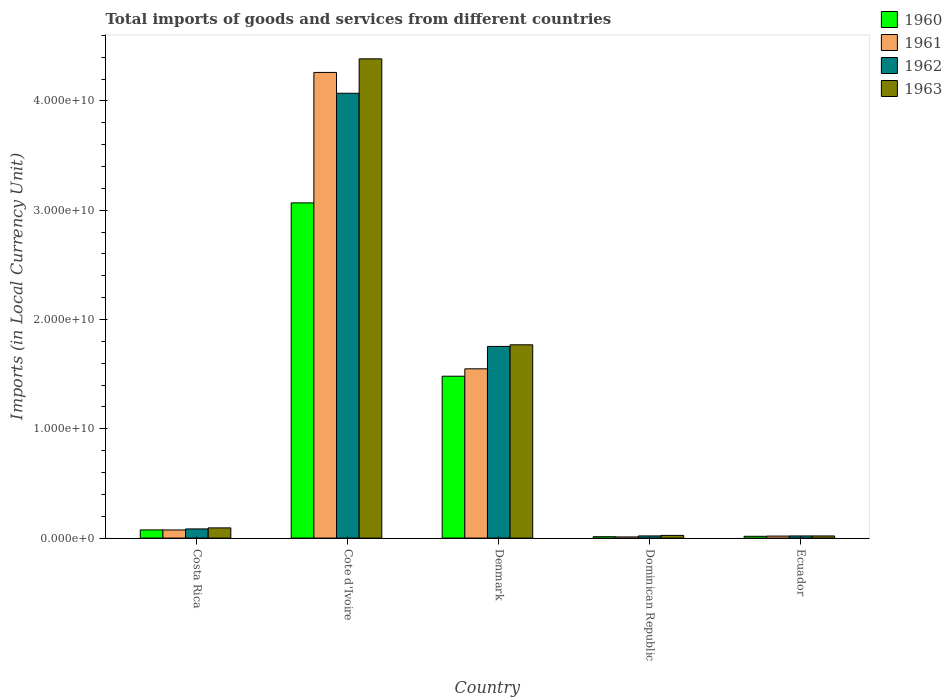How many different coloured bars are there?
Offer a very short reply. 4. Are the number of bars per tick equal to the number of legend labels?
Offer a terse response. Yes. How many bars are there on the 1st tick from the right?
Your answer should be very brief. 4. What is the label of the 2nd group of bars from the left?
Your answer should be compact. Cote d'Ivoire. What is the Amount of goods and services imports in 1960 in Ecuador?
Give a very brief answer. 1.64e+08. Across all countries, what is the maximum Amount of goods and services imports in 1960?
Offer a very short reply. 3.07e+1. Across all countries, what is the minimum Amount of goods and services imports in 1962?
Make the answer very short. 1.97e+08. In which country was the Amount of goods and services imports in 1963 maximum?
Your response must be concise. Cote d'Ivoire. In which country was the Amount of goods and services imports in 1962 minimum?
Keep it short and to the point. Ecuador. What is the total Amount of goods and services imports in 1961 in the graph?
Provide a short and direct response. 5.91e+1. What is the difference between the Amount of goods and services imports in 1962 in Costa Rica and that in Ecuador?
Offer a very short reply. 6.43e+08. What is the difference between the Amount of goods and services imports in 1962 in Cote d'Ivoire and the Amount of goods and services imports in 1963 in Dominican Republic?
Offer a terse response. 4.05e+1. What is the average Amount of goods and services imports in 1960 per country?
Provide a short and direct response. 9.31e+09. What is the difference between the Amount of goods and services imports of/in 1962 and Amount of goods and services imports of/in 1960 in Cote d'Ivoire?
Your response must be concise. 1.00e+1. What is the ratio of the Amount of goods and services imports in 1962 in Costa Rica to that in Cote d'Ivoire?
Ensure brevity in your answer.  0.02. Is the difference between the Amount of goods and services imports in 1962 in Costa Rica and Dominican Republic greater than the difference between the Amount of goods and services imports in 1960 in Costa Rica and Dominican Republic?
Make the answer very short. Yes. What is the difference between the highest and the second highest Amount of goods and services imports in 1962?
Keep it short and to the point. 1.67e+1. What is the difference between the highest and the lowest Amount of goods and services imports in 1963?
Your answer should be compact. 4.37e+1. In how many countries, is the Amount of goods and services imports in 1960 greater than the average Amount of goods and services imports in 1960 taken over all countries?
Give a very brief answer. 2. What does the 3rd bar from the left in Cote d'Ivoire represents?
Provide a succinct answer. 1962. What does the 4th bar from the right in Costa Rica represents?
Your answer should be very brief. 1960. Is it the case that in every country, the sum of the Amount of goods and services imports in 1962 and Amount of goods and services imports in 1960 is greater than the Amount of goods and services imports in 1961?
Your response must be concise. Yes. How many bars are there?
Offer a very short reply. 20. How many countries are there in the graph?
Provide a succinct answer. 5. What is the difference between two consecutive major ticks on the Y-axis?
Ensure brevity in your answer.  1.00e+1. Are the values on the major ticks of Y-axis written in scientific E-notation?
Make the answer very short. Yes. Does the graph contain any zero values?
Offer a very short reply. No. What is the title of the graph?
Ensure brevity in your answer.  Total imports of goods and services from different countries. What is the label or title of the Y-axis?
Ensure brevity in your answer.  Imports (in Local Currency Unit). What is the Imports (in Local Currency Unit) of 1960 in Costa Rica?
Ensure brevity in your answer.  7.49e+08. What is the Imports (in Local Currency Unit) in 1961 in Costa Rica?
Give a very brief answer. 7.44e+08. What is the Imports (in Local Currency Unit) in 1962 in Costa Rica?
Give a very brief answer. 8.40e+08. What is the Imports (in Local Currency Unit) in 1963 in Costa Rica?
Offer a very short reply. 9.34e+08. What is the Imports (in Local Currency Unit) in 1960 in Cote d'Ivoire?
Provide a short and direct response. 3.07e+1. What is the Imports (in Local Currency Unit) in 1961 in Cote d'Ivoire?
Keep it short and to the point. 4.26e+1. What is the Imports (in Local Currency Unit) of 1962 in Cote d'Ivoire?
Make the answer very short. 4.07e+1. What is the Imports (in Local Currency Unit) in 1963 in Cote d'Ivoire?
Keep it short and to the point. 4.39e+1. What is the Imports (in Local Currency Unit) of 1960 in Denmark?
Provide a short and direct response. 1.48e+1. What is the Imports (in Local Currency Unit) of 1961 in Denmark?
Your response must be concise. 1.55e+1. What is the Imports (in Local Currency Unit) in 1962 in Denmark?
Offer a very short reply. 1.75e+1. What is the Imports (in Local Currency Unit) in 1963 in Denmark?
Offer a terse response. 1.77e+1. What is the Imports (in Local Currency Unit) of 1960 in Dominican Republic?
Ensure brevity in your answer.  1.26e+08. What is the Imports (in Local Currency Unit) in 1961 in Dominican Republic?
Offer a very short reply. 1.07e+08. What is the Imports (in Local Currency Unit) in 1962 in Dominican Republic?
Give a very brief answer. 1.99e+08. What is the Imports (in Local Currency Unit) of 1963 in Dominican Republic?
Provide a succinct answer. 2.44e+08. What is the Imports (in Local Currency Unit) in 1960 in Ecuador?
Provide a succinct answer. 1.64e+08. What is the Imports (in Local Currency Unit) of 1961 in Ecuador?
Give a very brief answer. 1.83e+08. What is the Imports (in Local Currency Unit) of 1962 in Ecuador?
Provide a succinct answer. 1.97e+08. What is the Imports (in Local Currency Unit) in 1963 in Ecuador?
Provide a succinct answer. 1.96e+08. Across all countries, what is the maximum Imports (in Local Currency Unit) of 1960?
Make the answer very short. 3.07e+1. Across all countries, what is the maximum Imports (in Local Currency Unit) of 1961?
Offer a very short reply. 4.26e+1. Across all countries, what is the maximum Imports (in Local Currency Unit) in 1962?
Ensure brevity in your answer.  4.07e+1. Across all countries, what is the maximum Imports (in Local Currency Unit) in 1963?
Your answer should be compact. 4.39e+1. Across all countries, what is the minimum Imports (in Local Currency Unit) of 1960?
Your response must be concise. 1.26e+08. Across all countries, what is the minimum Imports (in Local Currency Unit) in 1961?
Make the answer very short. 1.07e+08. Across all countries, what is the minimum Imports (in Local Currency Unit) of 1962?
Your response must be concise. 1.97e+08. Across all countries, what is the minimum Imports (in Local Currency Unit) of 1963?
Offer a terse response. 1.96e+08. What is the total Imports (in Local Currency Unit) of 1960 in the graph?
Keep it short and to the point. 4.65e+1. What is the total Imports (in Local Currency Unit) of 1961 in the graph?
Your response must be concise. 5.91e+1. What is the total Imports (in Local Currency Unit) in 1962 in the graph?
Your answer should be very brief. 5.95e+1. What is the total Imports (in Local Currency Unit) in 1963 in the graph?
Ensure brevity in your answer.  6.29e+1. What is the difference between the Imports (in Local Currency Unit) of 1960 in Costa Rica and that in Cote d'Ivoire?
Provide a short and direct response. -2.99e+1. What is the difference between the Imports (in Local Currency Unit) of 1961 in Costa Rica and that in Cote d'Ivoire?
Ensure brevity in your answer.  -4.19e+1. What is the difference between the Imports (in Local Currency Unit) in 1962 in Costa Rica and that in Cote d'Ivoire?
Your response must be concise. -3.99e+1. What is the difference between the Imports (in Local Currency Unit) of 1963 in Costa Rica and that in Cote d'Ivoire?
Keep it short and to the point. -4.29e+1. What is the difference between the Imports (in Local Currency Unit) in 1960 in Costa Rica and that in Denmark?
Keep it short and to the point. -1.41e+1. What is the difference between the Imports (in Local Currency Unit) of 1961 in Costa Rica and that in Denmark?
Give a very brief answer. -1.47e+1. What is the difference between the Imports (in Local Currency Unit) of 1962 in Costa Rica and that in Denmark?
Provide a short and direct response. -1.67e+1. What is the difference between the Imports (in Local Currency Unit) of 1963 in Costa Rica and that in Denmark?
Make the answer very short. -1.68e+1. What is the difference between the Imports (in Local Currency Unit) of 1960 in Costa Rica and that in Dominican Republic?
Keep it short and to the point. 6.22e+08. What is the difference between the Imports (in Local Currency Unit) of 1961 in Costa Rica and that in Dominican Republic?
Offer a very short reply. 6.37e+08. What is the difference between the Imports (in Local Currency Unit) of 1962 in Costa Rica and that in Dominican Republic?
Keep it short and to the point. 6.40e+08. What is the difference between the Imports (in Local Currency Unit) in 1963 in Costa Rica and that in Dominican Republic?
Offer a very short reply. 6.90e+08. What is the difference between the Imports (in Local Currency Unit) in 1960 in Costa Rica and that in Ecuador?
Provide a succinct answer. 5.85e+08. What is the difference between the Imports (in Local Currency Unit) of 1961 in Costa Rica and that in Ecuador?
Your answer should be compact. 5.61e+08. What is the difference between the Imports (in Local Currency Unit) in 1962 in Costa Rica and that in Ecuador?
Your response must be concise. 6.43e+08. What is the difference between the Imports (in Local Currency Unit) of 1963 in Costa Rica and that in Ecuador?
Your response must be concise. 7.38e+08. What is the difference between the Imports (in Local Currency Unit) in 1960 in Cote d'Ivoire and that in Denmark?
Give a very brief answer. 1.59e+1. What is the difference between the Imports (in Local Currency Unit) of 1961 in Cote d'Ivoire and that in Denmark?
Offer a very short reply. 2.71e+1. What is the difference between the Imports (in Local Currency Unit) in 1962 in Cote d'Ivoire and that in Denmark?
Your answer should be very brief. 2.32e+1. What is the difference between the Imports (in Local Currency Unit) of 1963 in Cote d'Ivoire and that in Denmark?
Ensure brevity in your answer.  2.62e+1. What is the difference between the Imports (in Local Currency Unit) of 1960 in Cote d'Ivoire and that in Dominican Republic?
Your answer should be very brief. 3.05e+1. What is the difference between the Imports (in Local Currency Unit) in 1961 in Cote d'Ivoire and that in Dominican Republic?
Ensure brevity in your answer.  4.25e+1. What is the difference between the Imports (in Local Currency Unit) of 1962 in Cote d'Ivoire and that in Dominican Republic?
Ensure brevity in your answer.  4.05e+1. What is the difference between the Imports (in Local Currency Unit) of 1963 in Cote d'Ivoire and that in Dominican Republic?
Make the answer very short. 4.36e+1. What is the difference between the Imports (in Local Currency Unit) in 1960 in Cote d'Ivoire and that in Ecuador?
Make the answer very short. 3.05e+1. What is the difference between the Imports (in Local Currency Unit) in 1961 in Cote d'Ivoire and that in Ecuador?
Give a very brief answer. 4.24e+1. What is the difference between the Imports (in Local Currency Unit) of 1962 in Cote d'Ivoire and that in Ecuador?
Ensure brevity in your answer.  4.05e+1. What is the difference between the Imports (in Local Currency Unit) in 1963 in Cote d'Ivoire and that in Ecuador?
Your answer should be very brief. 4.37e+1. What is the difference between the Imports (in Local Currency Unit) in 1960 in Denmark and that in Dominican Republic?
Make the answer very short. 1.47e+1. What is the difference between the Imports (in Local Currency Unit) in 1961 in Denmark and that in Dominican Republic?
Give a very brief answer. 1.54e+1. What is the difference between the Imports (in Local Currency Unit) in 1962 in Denmark and that in Dominican Republic?
Your response must be concise. 1.73e+1. What is the difference between the Imports (in Local Currency Unit) of 1963 in Denmark and that in Dominican Republic?
Your response must be concise. 1.74e+1. What is the difference between the Imports (in Local Currency Unit) in 1960 in Denmark and that in Ecuador?
Your response must be concise. 1.47e+1. What is the difference between the Imports (in Local Currency Unit) of 1961 in Denmark and that in Ecuador?
Keep it short and to the point. 1.53e+1. What is the difference between the Imports (in Local Currency Unit) in 1962 in Denmark and that in Ecuador?
Keep it short and to the point. 1.73e+1. What is the difference between the Imports (in Local Currency Unit) in 1963 in Denmark and that in Ecuador?
Your answer should be very brief. 1.75e+1. What is the difference between the Imports (in Local Currency Unit) in 1960 in Dominican Republic and that in Ecuador?
Your answer should be compact. -3.75e+07. What is the difference between the Imports (in Local Currency Unit) in 1961 in Dominican Republic and that in Ecuador?
Give a very brief answer. -7.66e+07. What is the difference between the Imports (in Local Currency Unit) in 1962 in Dominican Republic and that in Ecuador?
Offer a very short reply. 2.37e+06. What is the difference between the Imports (in Local Currency Unit) of 1963 in Dominican Republic and that in Ecuador?
Keep it short and to the point. 4.81e+07. What is the difference between the Imports (in Local Currency Unit) in 1960 in Costa Rica and the Imports (in Local Currency Unit) in 1961 in Cote d'Ivoire?
Your answer should be compact. -4.19e+1. What is the difference between the Imports (in Local Currency Unit) in 1960 in Costa Rica and the Imports (in Local Currency Unit) in 1962 in Cote d'Ivoire?
Provide a succinct answer. -4.00e+1. What is the difference between the Imports (in Local Currency Unit) in 1960 in Costa Rica and the Imports (in Local Currency Unit) in 1963 in Cote d'Ivoire?
Make the answer very short. -4.31e+1. What is the difference between the Imports (in Local Currency Unit) in 1961 in Costa Rica and the Imports (in Local Currency Unit) in 1962 in Cote d'Ivoire?
Your response must be concise. -4.00e+1. What is the difference between the Imports (in Local Currency Unit) in 1961 in Costa Rica and the Imports (in Local Currency Unit) in 1963 in Cote d'Ivoire?
Offer a very short reply. -4.31e+1. What is the difference between the Imports (in Local Currency Unit) in 1962 in Costa Rica and the Imports (in Local Currency Unit) in 1963 in Cote d'Ivoire?
Your response must be concise. -4.30e+1. What is the difference between the Imports (in Local Currency Unit) of 1960 in Costa Rica and the Imports (in Local Currency Unit) of 1961 in Denmark?
Your response must be concise. -1.47e+1. What is the difference between the Imports (in Local Currency Unit) of 1960 in Costa Rica and the Imports (in Local Currency Unit) of 1962 in Denmark?
Your answer should be compact. -1.68e+1. What is the difference between the Imports (in Local Currency Unit) of 1960 in Costa Rica and the Imports (in Local Currency Unit) of 1963 in Denmark?
Ensure brevity in your answer.  -1.69e+1. What is the difference between the Imports (in Local Currency Unit) of 1961 in Costa Rica and the Imports (in Local Currency Unit) of 1962 in Denmark?
Your answer should be very brief. -1.68e+1. What is the difference between the Imports (in Local Currency Unit) in 1961 in Costa Rica and the Imports (in Local Currency Unit) in 1963 in Denmark?
Provide a short and direct response. -1.69e+1. What is the difference between the Imports (in Local Currency Unit) in 1962 in Costa Rica and the Imports (in Local Currency Unit) in 1963 in Denmark?
Your response must be concise. -1.68e+1. What is the difference between the Imports (in Local Currency Unit) of 1960 in Costa Rica and the Imports (in Local Currency Unit) of 1961 in Dominican Republic?
Give a very brief answer. 6.42e+08. What is the difference between the Imports (in Local Currency Unit) of 1960 in Costa Rica and the Imports (in Local Currency Unit) of 1962 in Dominican Republic?
Offer a terse response. 5.50e+08. What is the difference between the Imports (in Local Currency Unit) in 1960 in Costa Rica and the Imports (in Local Currency Unit) in 1963 in Dominican Republic?
Provide a succinct answer. 5.04e+08. What is the difference between the Imports (in Local Currency Unit) of 1961 in Costa Rica and the Imports (in Local Currency Unit) of 1962 in Dominican Republic?
Ensure brevity in your answer.  5.45e+08. What is the difference between the Imports (in Local Currency Unit) in 1961 in Costa Rica and the Imports (in Local Currency Unit) in 1963 in Dominican Republic?
Offer a terse response. 5.00e+08. What is the difference between the Imports (in Local Currency Unit) of 1962 in Costa Rica and the Imports (in Local Currency Unit) of 1963 in Dominican Republic?
Provide a succinct answer. 5.95e+08. What is the difference between the Imports (in Local Currency Unit) in 1960 in Costa Rica and the Imports (in Local Currency Unit) in 1961 in Ecuador?
Ensure brevity in your answer.  5.65e+08. What is the difference between the Imports (in Local Currency Unit) of 1960 in Costa Rica and the Imports (in Local Currency Unit) of 1962 in Ecuador?
Keep it short and to the point. 5.52e+08. What is the difference between the Imports (in Local Currency Unit) of 1960 in Costa Rica and the Imports (in Local Currency Unit) of 1963 in Ecuador?
Offer a terse response. 5.53e+08. What is the difference between the Imports (in Local Currency Unit) in 1961 in Costa Rica and the Imports (in Local Currency Unit) in 1962 in Ecuador?
Keep it short and to the point. 5.47e+08. What is the difference between the Imports (in Local Currency Unit) of 1961 in Costa Rica and the Imports (in Local Currency Unit) of 1963 in Ecuador?
Give a very brief answer. 5.48e+08. What is the difference between the Imports (in Local Currency Unit) of 1962 in Costa Rica and the Imports (in Local Currency Unit) of 1963 in Ecuador?
Ensure brevity in your answer.  6.43e+08. What is the difference between the Imports (in Local Currency Unit) in 1960 in Cote d'Ivoire and the Imports (in Local Currency Unit) in 1961 in Denmark?
Provide a short and direct response. 1.52e+1. What is the difference between the Imports (in Local Currency Unit) in 1960 in Cote d'Ivoire and the Imports (in Local Currency Unit) in 1962 in Denmark?
Give a very brief answer. 1.31e+1. What is the difference between the Imports (in Local Currency Unit) of 1960 in Cote d'Ivoire and the Imports (in Local Currency Unit) of 1963 in Denmark?
Offer a very short reply. 1.30e+1. What is the difference between the Imports (in Local Currency Unit) of 1961 in Cote d'Ivoire and the Imports (in Local Currency Unit) of 1962 in Denmark?
Offer a very short reply. 2.51e+1. What is the difference between the Imports (in Local Currency Unit) in 1961 in Cote d'Ivoire and the Imports (in Local Currency Unit) in 1963 in Denmark?
Give a very brief answer. 2.49e+1. What is the difference between the Imports (in Local Currency Unit) of 1962 in Cote d'Ivoire and the Imports (in Local Currency Unit) of 1963 in Denmark?
Ensure brevity in your answer.  2.30e+1. What is the difference between the Imports (in Local Currency Unit) in 1960 in Cote d'Ivoire and the Imports (in Local Currency Unit) in 1961 in Dominican Republic?
Offer a terse response. 3.06e+1. What is the difference between the Imports (in Local Currency Unit) of 1960 in Cote d'Ivoire and the Imports (in Local Currency Unit) of 1962 in Dominican Republic?
Keep it short and to the point. 3.05e+1. What is the difference between the Imports (in Local Currency Unit) in 1960 in Cote d'Ivoire and the Imports (in Local Currency Unit) in 1963 in Dominican Republic?
Offer a terse response. 3.04e+1. What is the difference between the Imports (in Local Currency Unit) in 1961 in Cote d'Ivoire and the Imports (in Local Currency Unit) in 1962 in Dominican Republic?
Provide a succinct answer. 4.24e+1. What is the difference between the Imports (in Local Currency Unit) of 1961 in Cote d'Ivoire and the Imports (in Local Currency Unit) of 1963 in Dominican Republic?
Your response must be concise. 4.24e+1. What is the difference between the Imports (in Local Currency Unit) of 1962 in Cote d'Ivoire and the Imports (in Local Currency Unit) of 1963 in Dominican Republic?
Ensure brevity in your answer.  4.05e+1. What is the difference between the Imports (in Local Currency Unit) of 1960 in Cote d'Ivoire and the Imports (in Local Currency Unit) of 1961 in Ecuador?
Your answer should be compact. 3.05e+1. What is the difference between the Imports (in Local Currency Unit) of 1960 in Cote d'Ivoire and the Imports (in Local Currency Unit) of 1962 in Ecuador?
Give a very brief answer. 3.05e+1. What is the difference between the Imports (in Local Currency Unit) of 1960 in Cote d'Ivoire and the Imports (in Local Currency Unit) of 1963 in Ecuador?
Make the answer very short. 3.05e+1. What is the difference between the Imports (in Local Currency Unit) in 1961 in Cote d'Ivoire and the Imports (in Local Currency Unit) in 1962 in Ecuador?
Your answer should be very brief. 4.24e+1. What is the difference between the Imports (in Local Currency Unit) of 1961 in Cote d'Ivoire and the Imports (in Local Currency Unit) of 1963 in Ecuador?
Make the answer very short. 4.24e+1. What is the difference between the Imports (in Local Currency Unit) of 1962 in Cote d'Ivoire and the Imports (in Local Currency Unit) of 1963 in Ecuador?
Your response must be concise. 4.05e+1. What is the difference between the Imports (in Local Currency Unit) of 1960 in Denmark and the Imports (in Local Currency Unit) of 1961 in Dominican Republic?
Provide a succinct answer. 1.47e+1. What is the difference between the Imports (in Local Currency Unit) in 1960 in Denmark and the Imports (in Local Currency Unit) in 1962 in Dominican Republic?
Your answer should be very brief. 1.46e+1. What is the difference between the Imports (in Local Currency Unit) of 1960 in Denmark and the Imports (in Local Currency Unit) of 1963 in Dominican Republic?
Your answer should be compact. 1.46e+1. What is the difference between the Imports (in Local Currency Unit) of 1961 in Denmark and the Imports (in Local Currency Unit) of 1962 in Dominican Republic?
Offer a very short reply. 1.53e+1. What is the difference between the Imports (in Local Currency Unit) of 1961 in Denmark and the Imports (in Local Currency Unit) of 1963 in Dominican Republic?
Give a very brief answer. 1.52e+1. What is the difference between the Imports (in Local Currency Unit) of 1962 in Denmark and the Imports (in Local Currency Unit) of 1963 in Dominican Republic?
Your response must be concise. 1.73e+1. What is the difference between the Imports (in Local Currency Unit) in 1960 in Denmark and the Imports (in Local Currency Unit) in 1961 in Ecuador?
Your answer should be compact. 1.46e+1. What is the difference between the Imports (in Local Currency Unit) in 1960 in Denmark and the Imports (in Local Currency Unit) in 1962 in Ecuador?
Provide a succinct answer. 1.46e+1. What is the difference between the Imports (in Local Currency Unit) in 1960 in Denmark and the Imports (in Local Currency Unit) in 1963 in Ecuador?
Provide a short and direct response. 1.46e+1. What is the difference between the Imports (in Local Currency Unit) in 1961 in Denmark and the Imports (in Local Currency Unit) in 1962 in Ecuador?
Give a very brief answer. 1.53e+1. What is the difference between the Imports (in Local Currency Unit) of 1961 in Denmark and the Imports (in Local Currency Unit) of 1963 in Ecuador?
Provide a succinct answer. 1.53e+1. What is the difference between the Imports (in Local Currency Unit) in 1962 in Denmark and the Imports (in Local Currency Unit) in 1963 in Ecuador?
Your answer should be very brief. 1.73e+1. What is the difference between the Imports (in Local Currency Unit) of 1960 in Dominican Republic and the Imports (in Local Currency Unit) of 1961 in Ecuador?
Offer a very short reply. -5.70e+07. What is the difference between the Imports (in Local Currency Unit) of 1960 in Dominican Republic and the Imports (in Local Currency Unit) of 1962 in Ecuador?
Give a very brief answer. -7.04e+07. What is the difference between the Imports (in Local Currency Unit) of 1960 in Dominican Republic and the Imports (in Local Currency Unit) of 1963 in Ecuador?
Provide a short and direct response. -6.98e+07. What is the difference between the Imports (in Local Currency Unit) of 1961 in Dominican Republic and the Imports (in Local Currency Unit) of 1962 in Ecuador?
Ensure brevity in your answer.  -9.00e+07. What is the difference between the Imports (in Local Currency Unit) of 1961 in Dominican Republic and the Imports (in Local Currency Unit) of 1963 in Ecuador?
Keep it short and to the point. -8.94e+07. What is the difference between the Imports (in Local Currency Unit) in 1962 in Dominican Republic and the Imports (in Local Currency Unit) in 1963 in Ecuador?
Provide a short and direct response. 3.04e+06. What is the average Imports (in Local Currency Unit) of 1960 per country?
Make the answer very short. 9.31e+09. What is the average Imports (in Local Currency Unit) in 1961 per country?
Keep it short and to the point. 1.18e+1. What is the average Imports (in Local Currency Unit) of 1962 per country?
Provide a short and direct response. 1.19e+1. What is the average Imports (in Local Currency Unit) in 1963 per country?
Ensure brevity in your answer.  1.26e+1. What is the difference between the Imports (in Local Currency Unit) of 1960 and Imports (in Local Currency Unit) of 1961 in Costa Rica?
Your response must be concise. 4.80e+06. What is the difference between the Imports (in Local Currency Unit) in 1960 and Imports (in Local Currency Unit) in 1962 in Costa Rica?
Offer a very short reply. -9.07e+07. What is the difference between the Imports (in Local Currency Unit) of 1960 and Imports (in Local Currency Unit) of 1963 in Costa Rica?
Keep it short and to the point. -1.85e+08. What is the difference between the Imports (in Local Currency Unit) in 1961 and Imports (in Local Currency Unit) in 1962 in Costa Rica?
Your answer should be very brief. -9.55e+07. What is the difference between the Imports (in Local Currency Unit) of 1961 and Imports (in Local Currency Unit) of 1963 in Costa Rica?
Your answer should be compact. -1.90e+08. What is the difference between the Imports (in Local Currency Unit) of 1962 and Imports (in Local Currency Unit) of 1963 in Costa Rica?
Keep it short and to the point. -9.44e+07. What is the difference between the Imports (in Local Currency Unit) of 1960 and Imports (in Local Currency Unit) of 1961 in Cote d'Ivoire?
Your response must be concise. -1.19e+1. What is the difference between the Imports (in Local Currency Unit) in 1960 and Imports (in Local Currency Unit) in 1962 in Cote d'Ivoire?
Your answer should be very brief. -1.00e+1. What is the difference between the Imports (in Local Currency Unit) in 1960 and Imports (in Local Currency Unit) in 1963 in Cote d'Ivoire?
Offer a terse response. -1.32e+1. What is the difference between the Imports (in Local Currency Unit) of 1961 and Imports (in Local Currency Unit) of 1962 in Cote d'Ivoire?
Offer a terse response. 1.91e+09. What is the difference between the Imports (in Local Currency Unit) of 1961 and Imports (in Local Currency Unit) of 1963 in Cote d'Ivoire?
Provide a succinct answer. -1.24e+09. What is the difference between the Imports (in Local Currency Unit) of 1962 and Imports (in Local Currency Unit) of 1963 in Cote d'Ivoire?
Ensure brevity in your answer.  -3.15e+09. What is the difference between the Imports (in Local Currency Unit) of 1960 and Imports (in Local Currency Unit) of 1961 in Denmark?
Your answer should be compact. -6.76e+08. What is the difference between the Imports (in Local Currency Unit) in 1960 and Imports (in Local Currency Unit) in 1962 in Denmark?
Give a very brief answer. -2.73e+09. What is the difference between the Imports (in Local Currency Unit) in 1960 and Imports (in Local Currency Unit) in 1963 in Denmark?
Make the answer very short. -2.87e+09. What is the difference between the Imports (in Local Currency Unit) in 1961 and Imports (in Local Currency Unit) in 1962 in Denmark?
Ensure brevity in your answer.  -2.05e+09. What is the difference between the Imports (in Local Currency Unit) in 1961 and Imports (in Local Currency Unit) in 1963 in Denmark?
Ensure brevity in your answer.  -2.20e+09. What is the difference between the Imports (in Local Currency Unit) of 1962 and Imports (in Local Currency Unit) of 1963 in Denmark?
Ensure brevity in your answer.  -1.47e+08. What is the difference between the Imports (in Local Currency Unit) in 1960 and Imports (in Local Currency Unit) in 1961 in Dominican Republic?
Your response must be concise. 1.96e+07. What is the difference between the Imports (in Local Currency Unit) of 1960 and Imports (in Local Currency Unit) of 1962 in Dominican Republic?
Ensure brevity in your answer.  -7.28e+07. What is the difference between the Imports (in Local Currency Unit) in 1960 and Imports (in Local Currency Unit) in 1963 in Dominican Republic?
Keep it short and to the point. -1.18e+08. What is the difference between the Imports (in Local Currency Unit) of 1961 and Imports (in Local Currency Unit) of 1962 in Dominican Republic?
Your response must be concise. -9.24e+07. What is the difference between the Imports (in Local Currency Unit) of 1961 and Imports (in Local Currency Unit) of 1963 in Dominican Republic?
Give a very brief answer. -1.38e+08. What is the difference between the Imports (in Local Currency Unit) in 1962 and Imports (in Local Currency Unit) in 1963 in Dominican Republic?
Ensure brevity in your answer.  -4.51e+07. What is the difference between the Imports (in Local Currency Unit) in 1960 and Imports (in Local Currency Unit) in 1961 in Ecuador?
Offer a very short reply. -1.95e+07. What is the difference between the Imports (in Local Currency Unit) in 1960 and Imports (in Local Currency Unit) in 1962 in Ecuador?
Make the answer very short. -3.29e+07. What is the difference between the Imports (in Local Currency Unit) in 1960 and Imports (in Local Currency Unit) in 1963 in Ecuador?
Your response must be concise. -3.23e+07. What is the difference between the Imports (in Local Currency Unit) in 1961 and Imports (in Local Currency Unit) in 1962 in Ecuador?
Provide a short and direct response. -1.34e+07. What is the difference between the Imports (in Local Currency Unit) of 1961 and Imports (in Local Currency Unit) of 1963 in Ecuador?
Make the answer very short. -1.28e+07. What is the difference between the Imports (in Local Currency Unit) in 1962 and Imports (in Local Currency Unit) in 1963 in Ecuador?
Make the answer very short. 6.72e+05. What is the ratio of the Imports (in Local Currency Unit) in 1960 in Costa Rica to that in Cote d'Ivoire?
Keep it short and to the point. 0.02. What is the ratio of the Imports (in Local Currency Unit) of 1961 in Costa Rica to that in Cote d'Ivoire?
Your answer should be compact. 0.02. What is the ratio of the Imports (in Local Currency Unit) of 1962 in Costa Rica to that in Cote d'Ivoire?
Ensure brevity in your answer.  0.02. What is the ratio of the Imports (in Local Currency Unit) of 1963 in Costa Rica to that in Cote d'Ivoire?
Your answer should be very brief. 0.02. What is the ratio of the Imports (in Local Currency Unit) in 1960 in Costa Rica to that in Denmark?
Give a very brief answer. 0.05. What is the ratio of the Imports (in Local Currency Unit) in 1961 in Costa Rica to that in Denmark?
Offer a terse response. 0.05. What is the ratio of the Imports (in Local Currency Unit) of 1962 in Costa Rica to that in Denmark?
Offer a terse response. 0.05. What is the ratio of the Imports (in Local Currency Unit) in 1963 in Costa Rica to that in Denmark?
Offer a terse response. 0.05. What is the ratio of the Imports (in Local Currency Unit) in 1960 in Costa Rica to that in Dominican Republic?
Provide a succinct answer. 5.92. What is the ratio of the Imports (in Local Currency Unit) of 1961 in Costa Rica to that in Dominican Republic?
Offer a very short reply. 6.96. What is the ratio of the Imports (in Local Currency Unit) of 1962 in Costa Rica to that in Dominican Republic?
Make the answer very short. 4.21. What is the ratio of the Imports (in Local Currency Unit) of 1963 in Costa Rica to that in Dominican Republic?
Provide a succinct answer. 3.82. What is the ratio of the Imports (in Local Currency Unit) of 1960 in Costa Rica to that in Ecuador?
Give a very brief answer. 4.57. What is the ratio of the Imports (in Local Currency Unit) in 1961 in Costa Rica to that in Ecuador?
Your answer should be very brief. 4.05. What is the ratio of the Imports (in Local Currency Unit) of 1962 in Costa Rica to that in Ecuador?
Provide a short and direct response. 4.26. What is the ratio of the Imports (in Local Currency Unit) of 1963 in Costa Rica to that in Ecuador?
Offer a very short reply. 4.76. What is the ratio of the Imports (in Local Currency Unit) of 1960 in Cote d'Ivoire to that in Denmark?
Your response must be concise. 2.07. What is the ratio of the Imports (in Local Currency Unit) of 1961 in Cote d'Ivoire to that in Denmark?
Your answer should be very brief. 2.75. What is the ratio of the Imports (in Local Currency Unit) of 1962 in Cote d'Ivoire to that in Denmark?
Keep it short and to the point. 2.32. What is the ratio of the Imports (in Local Currency Unit) in 1963 in Cote d'Ivoire to that in Denmark?
Offer a terse response. 2.48. What is the ratio of the Imports (in Local Currency Unit) of 1960 in Cote d'Ivoire to that in Dominican Republic?
Your answer should be compact. 242.49. What is the ratio of the Imports (in Local Currency Unit) in 1961 in Cote d'Ivoire to that in Dominican Republic?
Your answer should be compact. 398.63. What is the ratio of the Imports (in Local Currency Unit) of 1962 in Cote d'Ivoire to that in Dominican Republic?
Your answer should be very brief. 204.25. What is the ratio of the Imports (in Local Currency Unit) of 1963 in Cote d'Ivoire to that in Dominican Republic?
Keep it short and to the point. 179.45. What is the ratio of the Imports (in Local Currency Unit) of 1960 in Cote d'Ivoire to that in Ecuador?
Offer a very short reply. 187.04. What is the ratio of the Imports (in Local Currency Unit) of 1961 in Cote d'Ivoire to that in Ecuador?
Ensure brevity in your answer.  232.24. What is the ratio of the Imports (in Local Currency Unit) in 1962 in Cote d'Ivoire to that in Ecuador?
Your answer should be compact. 206.7. What is the ratio of the Imports (in Local Currency Unit) in 1963 in Cote d'Ivoire to that in Ecuador?
Your answer should be compact. 223.46. What is the ratio of the Imports (in Local Currency Unit) in 1960 in Denmark to that in Dominican Republic?
Give a very brief answer. 117.11. What is the ratio of the Imports (in Local Currency Unit) of 1961 in Denmark to that in Dominican Republic?
Your response must be concise. 144.9. What is the ratio of the Imports (in Local Currency Unit) in 1962 in Denmark to that in Dominican Republic?
Offer a terse response. 88.01. What is the ratio of the Imports (in Local Currency Unit) in 1963 in Denmark to that in Dominican Republic?
Provide a succinct answer. 72.37. What is the ratio of the Imports (in Local Currency Unit) in 1960 in Denmark to that in Ecuador?
Give a very brief answer. 90.33. What is the ratio of the Imports (in Local Currency Unit) in 1961 in Denmark to that in Ecuador?
Ensure brevity in your answer.  84.42. What is the ratio of the Imports (in Local Currency Unit) in 1962 in Denmark to that in Ecuador?
Give a very brief answer. 89.07. What is the ratio of the Imports (in Local Currency Unit) of 1963 in Denmark to that in Ecuador?
Give a very brief answer. 90.12. What is the ratio of the Imports (in Local Currency Unit) of 1960 in Dominican Republic to that in Ecuador?
Provide a short and direct response. 0.77. What is the ratio of the Imports (in Local Currency Unit) of 1961 in Dominican Republic to that in Ecuador?
Provide a short and direct response. 0.58. What is the ratio of the Imports (in Local Currency Unit) in 1963 in Dominican Republic to that in Ecuador?
Your answer should be very brief. 1.25. What is the difference between the highest and the second highest Imports (in Local Currency Unit) in 1960?
Your answer should be compact. 1.59e+1. What is the difference between the highest and the second highest Imports (in Local Currency Unit) of 1961?
Provide a short and direct response. 2.71e+1. What is the difference between the highest and the second highest Imports (in Local Currency Unit) in 1962?
Offer a terse response. 2.32e+1. What is the difference between the highest and the second highest Imports (in Local Currency Unit) of 1963?
Offer a terse response. 2.62e+1. What is the difference between the highest and the lowest Imports (in Local Currency Unit) of 1960?
Provide a short and direct response. 3.05e+1. What is the difference between the highest and the lowest Imports (in Local Currency Unit) in 1961?
Keep it short and to the point. 4.25e+1. What is the difference between the highest and the lowest Imports (in Local Currency Unit) in 1962?
Offer a very short reply. 4.05e+1. What is the difference between the highest and the lowest Imports (in Local Currency Unit) of 1963?
Give a very brief answer. 4.37e+1. 